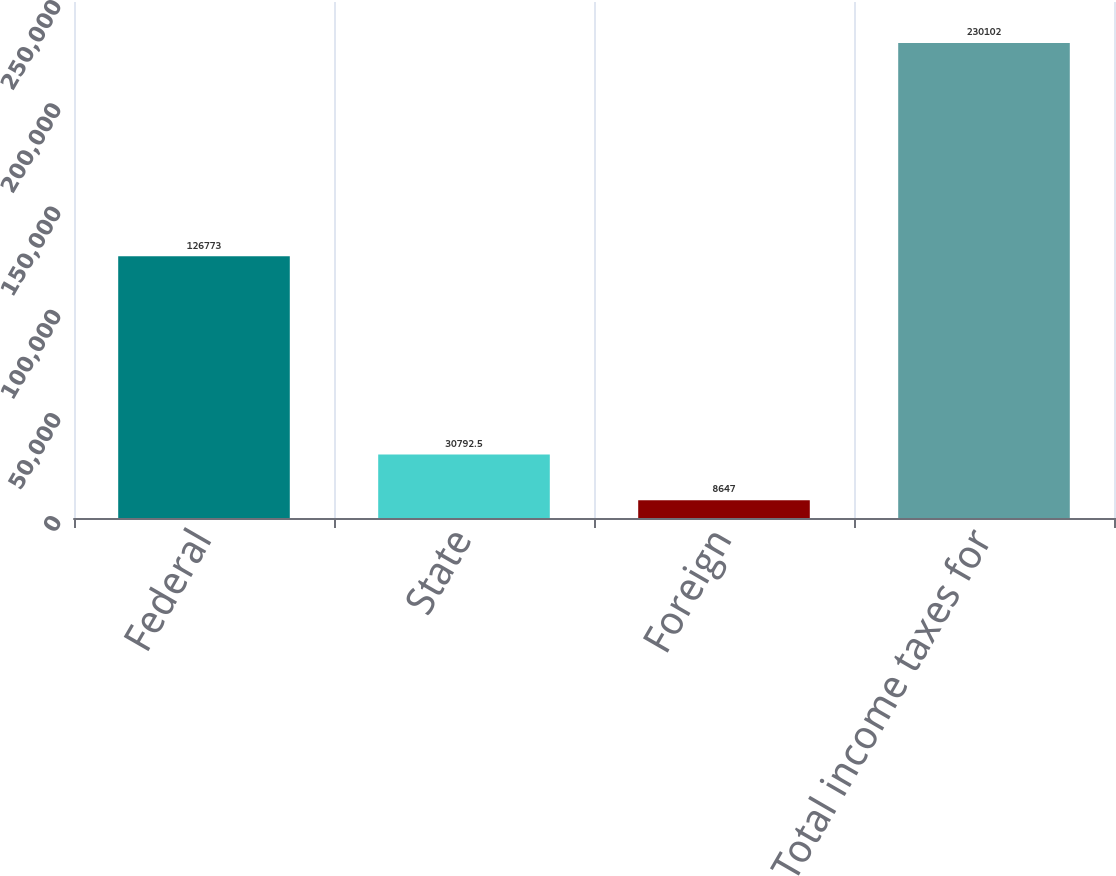Convert chart to OTSL. <chart><loc_0><loc_0><loc_500><loc_500><bar_chart><fcel>Federal<fcel>State<fcel>Foreign<fcel>Total income taxes for<nl><fcel>126773<fcel>30792.5<fcel>8647<fcel>230102<nl></chart> 